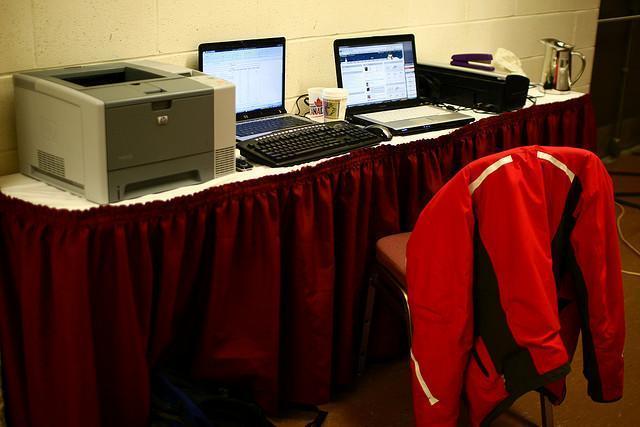How many keyboards are on the table?
Give a very brief answer. 2. How many laptops are visible?
Give a very brief answer. 2. 